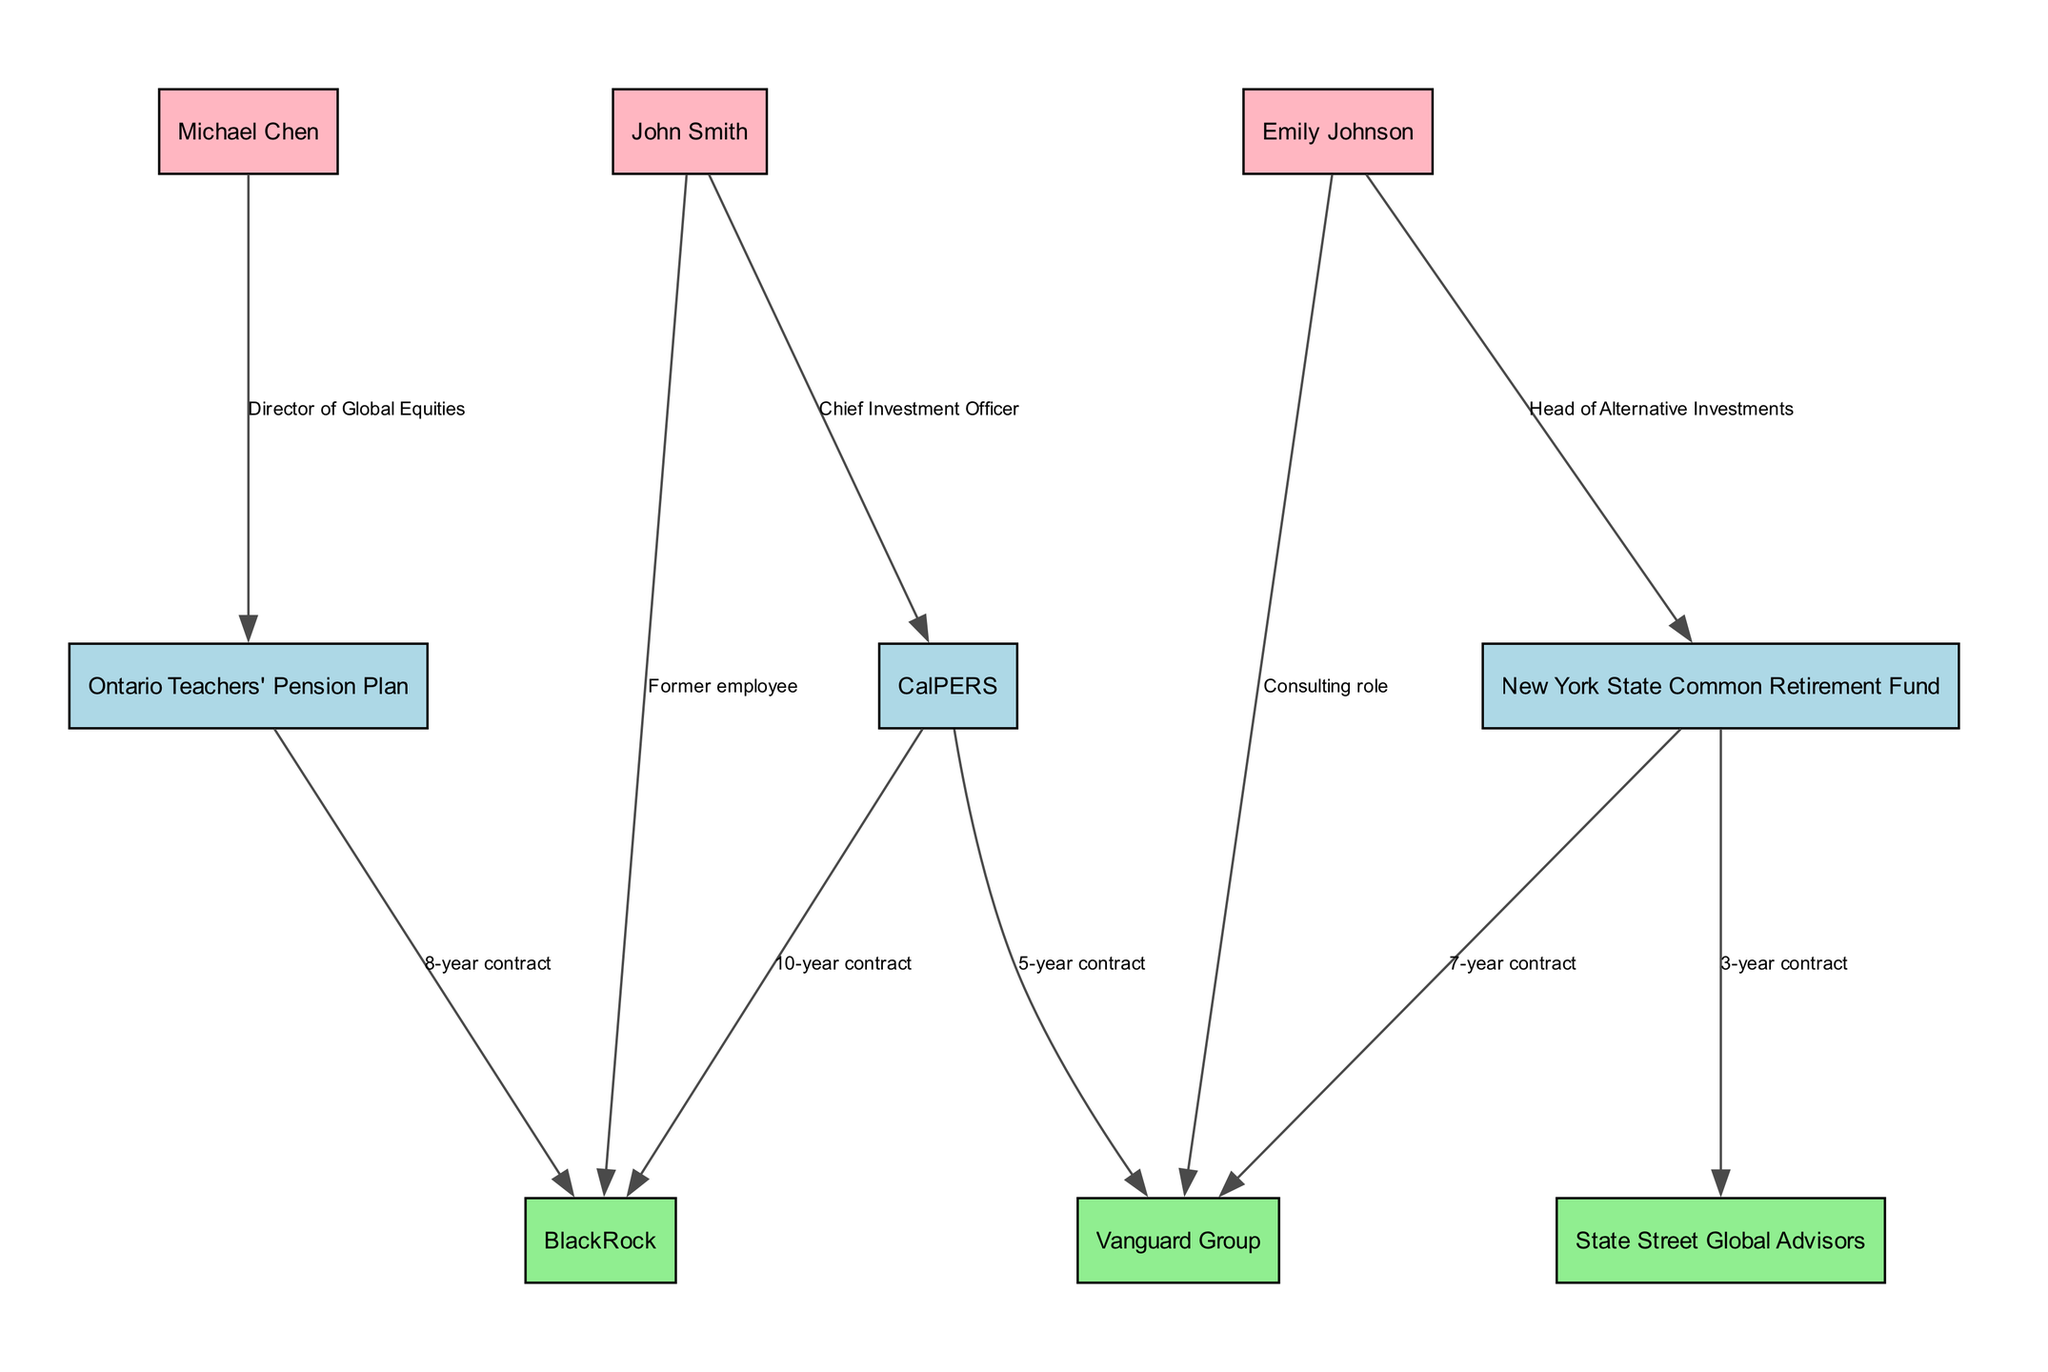What is the total number of pension funds represented in the diagram? The diagram contains three nodes classified as pension funds. Each is identifiable by the type label 'Pension Fund'. Counting these nodes gives us a total of three distinct pension funds represented.
Answer: 3 Which investment firm has the longest contract with a pension fund, and what is the duration? The longest contract listed is between CalPERS and BlackRock with a 10-year duration. This can be confirmed by examining the edges connecting the pension fund node to the investment firm node.
Answer: BlackRock, 10-year contract Who is the fund manager associated with the Ontario Teachers' Pension Plan? The diagram shows Michael Chen as the fund manager linked to the Ontario Teachers' Pension Plan. This connection is evident from the edge noted as 'Director of Global Equities', which identifies him in relation to that pension fund.
Answer: Michael Chen How many edges are connected to the New York State Common Retirement Fund? The New York State Common Retirement Fund has two outgoing edges connected to it: one to Vanguard Group and another to State Street Global Advisors. Counting these edges provides the answer.
Answer: 2 What type of relationship does Emily Johnson have with the New York State Common Retirement Fund? Emily Johnson is designated as the 'Head of Alternative Investments', which is indicated by the label on the edge connected to the New York State Common Retirement Fund. Therefore, her relationship type can be identified directly from the diagram.
Answer: Head of Alternative Investments Which two pension funds have a shared investment firm, and what is the firm? Both the New York State Common Retirement Fund and CalPERS have a shared investment firm, which is Vanguard Group. This relationship can be inferred by observing the edges connected to both pension fund nodes that lead to the same investment firm node.
Answer: New York State Common Retirement Fund, CalPERS; Vanguard Group What is the role of John Smith in relation to CalPERS? John Smith holds the role of 'Chief Investment Officer', as indicated by the label on the edge connecting him to the CalPERS node. This information clearly delineates his specific function within the pension fund in the diagram.
Answer: Chief Investment Officer How many investment firms are listed in the diagram? The diagram lists three distinct investment firms, identifiable by the type label 'Investment Firm'. A simple count of these nodes provides the answer.
Answer: 3 What is the total number of connections (edges) visible in the diagram? A thorough examination of the edges shows there are seven total connections represented in the diagram, which can be confirmed by counting each individual edge depicted.
Answer: 7 